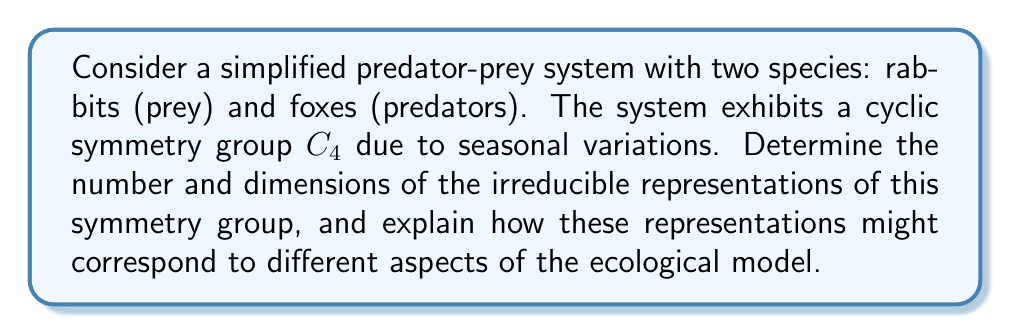What is the answer to this math problem? To analyze the irreducible representations of the cyclic symmetry group $C_4$ in this predator-prey system, we'll follow these steps:

1. Identify the group structure:
   $C_4$ is a cyclic group of order 4, generated by a single element $g$ such that $g^4 = e$ (identity).

2. Determine the number of conjugacy classes:
   In a cyclic group, each element forms its own conjugacy class. Therefore, $C_4$ has 4 conjugacy classes: $\{e\}, \{g\}, \{g^2\}, \{g^3\}$.

3. Calculate the number of irreducible representations:
   The number of irreducible representations is equal to the number of conjugacy classes. Thus, $C_4$ has 4 irreducible representations.

4. Find the dimensions of the irreducible representations:
   For a finite group $G$, the sum of the squares of the dimensions of its irreducible representations equals the order of the group:

   $$\sum_{i=1}^k d_i^2 = |G| = 4$$

   where $d_i$ are the dimensions of the irreducible representations.

   For cyclic groups, all irreducible representations are 1-dimensional. Therefore, we have:

   $$1^2 + 1^2 + 1^2 + 1^2 = 4$$

5. Characterize the irreducible representations:
   The irreducible representations of $C_4$ can be described as:
   
   $\rho_0(g^k) = 1$ (trivial representation)
   $\rho_1(g^k) = i^k$
   $\rho_2(g^k) = (-1)^k$
   $\rho_3(g^k) = (-i)^k$

   where $k = 0, 1, 2, 3$.

6. Interpret the representations in the context of the ecological model:
   - $\rho_0$: Represents the overall population dynamics invariant under seasonal changes.
   - $\rho_1$ and $\rho_3$: May correspond to oscillatory behaviors with a period of 4 seasons.
   - $\rho_2$: Could represent alternating behaviors between even and odd seasons.

These representations can help decompose the complex predator-prey dynamics into simpler, symmetry-adapted components, potentially revealing hidden patterns or simplifying the analysis of the ecological system.
Answer: 4 irreducible representations, all 1-dimensional: $\rho_0, \rho_1, \rho_2, \rho_3$ 